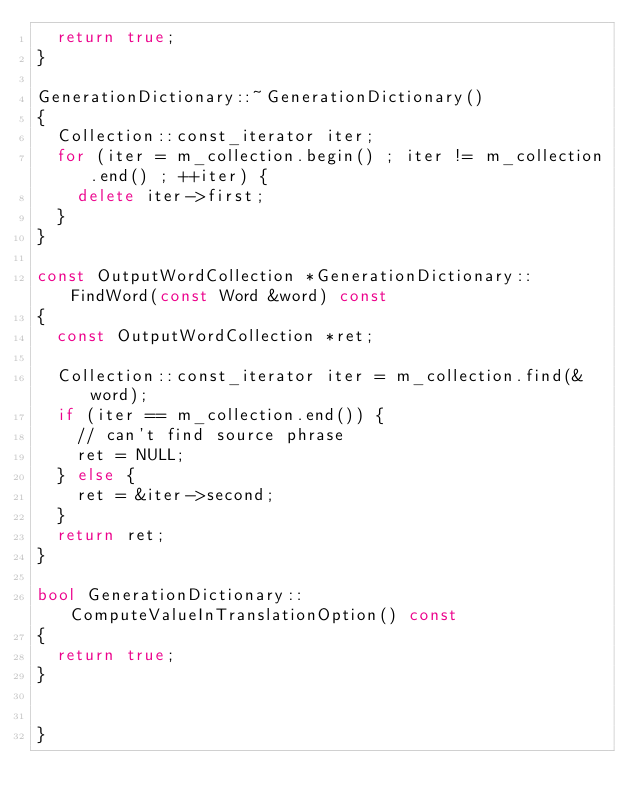<code> <loc_0><loc_0><loc_500><loc_500><_C++_>  return true;
}

GenerationDictionary::~GenerationDictionary()
{
  Collection::const_iterator iter;
  for (iter = m_collection.begin() ; iter != m_collection.end() ; ++iter) {
    delete iter->first;
  }
}

const OutputWordCollection *GenerationDictionary::FindWord(const Word &word) const
{
  const OutputWordCollection *ret;

  Collection::const_iterator iter = m_collection.find(&word);
  if (iter == m_collection.end()) {
    // can't find source phrase
    ret = NULL;
  } else {
    ret = &iter->second;
  }
  return ret;
}

bool GenerationDictionary::ComputeValueInTranslationOption() const
{
  return true;
}


}

</code> 